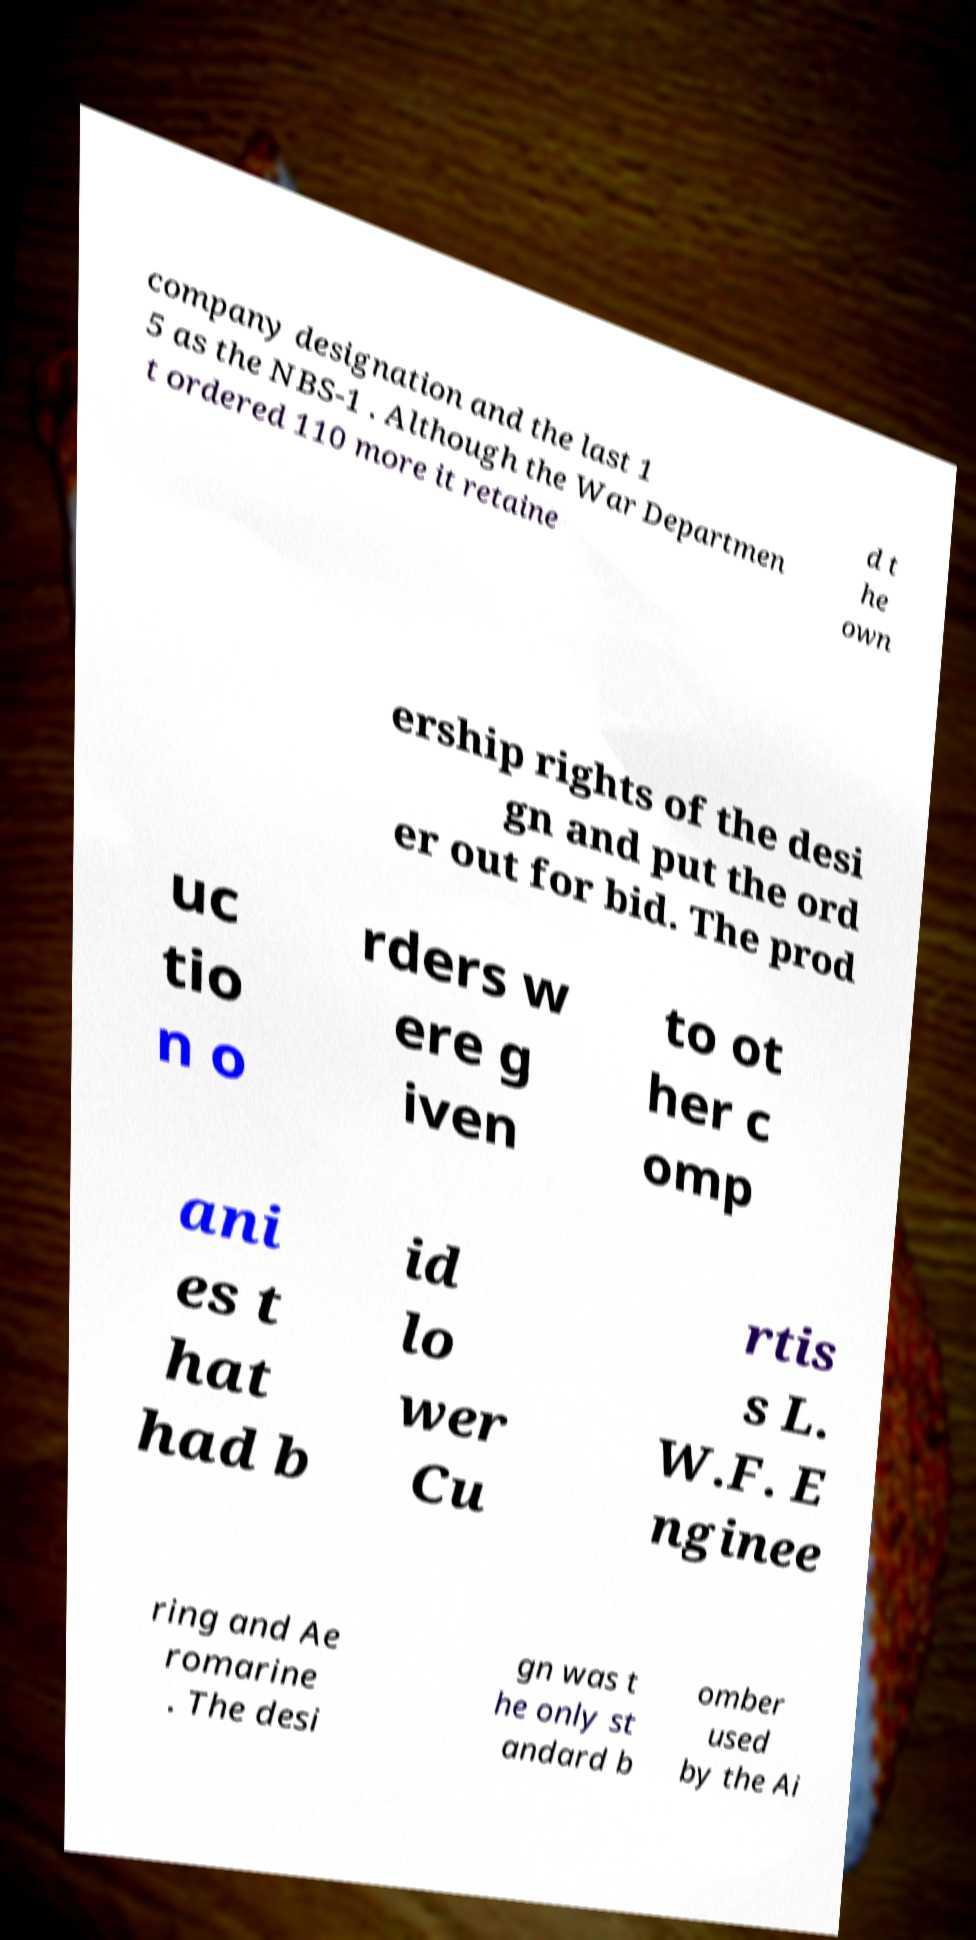Could you assist in decoding the text presented in this image and type it out clearly? company designation and the last 1 5 as the NBS-1 . Although the War Departmen t ordered 110 more it retaine d t he own ership rights of the desi gn and put the ord er out for bid. The prod uc tio n o rders w ere g iven to ot her c omp ani es t hat had b id lo wer Cu rtis s L. W.F. E nginee ring and Ae romarine . The desi gn was t he only st andard b omber used by the Ai 